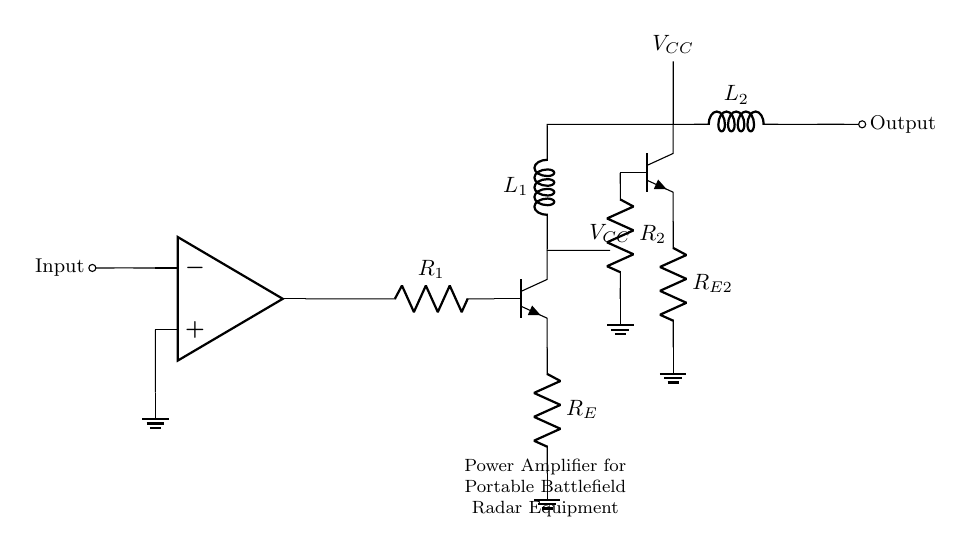What is the main component that amplifies the signal? The main component that amplifies the signal in this circuit is the operational amplifier, represented at the top of the circuit diagram. Its output is designed to provide a larger voltage to drive the subsequent transistors.
Answer: operational amplifier How many resistors are present in the circuit? There are three resistors in total: R1, RE, and R2. These resistors play different roles in regulating current and voltage levels in the amplifier circuit.
Answer: three What is the purpose of the inductor L1? The inductor L1 serves to couple or filter signals, helping to smooth out the frequency response of the amplifier by storing and releasing energy, which can enhance the circuit's performance at specific frequencies.
Answer: coupling What happens to the output if R2 is increased? Increasing R2 would generally result in a lower output current at the transistor Q2, which decreases the overall gain of the amplifier because it limits the base current flowing into the transistor.
Answer: decreases gain What is the role of the transistor Q1 in the circuit? The transistor Q1 acts as a current amplifier, assisting the operational amplifier by providing additional current gain necessary for driving the following stages of the amplifier.
Answer: current amplifier What is connected to the ground in this circuit? The ground connection is made at the lower ends of the resistors RE and R2, indicating a common reference point for all other voltages in the circuit, ensuring stable operation.
Answer: RE and R2 How does the circuit utilize VCC? The circuit utilizes VCC as the supply voltage for the transistors, ensuring they have enough power to operate and amplify the input signal effectively.
Answer: supply voltage 